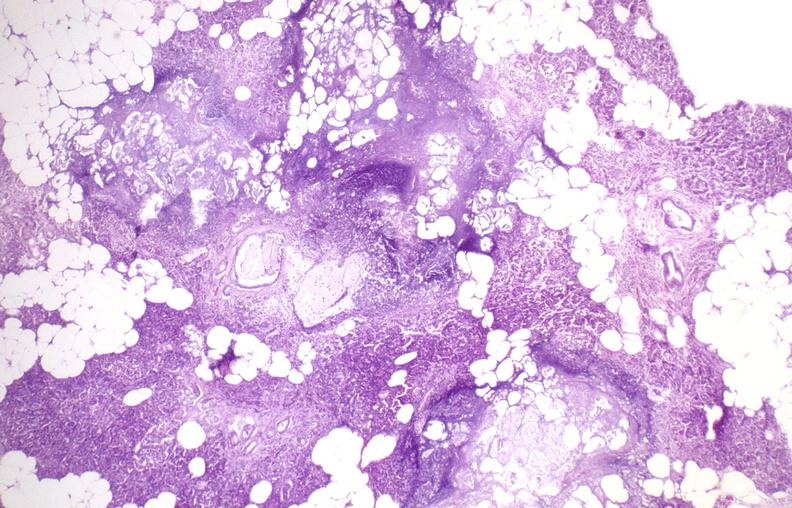does thymus show pancreatic fat necrosis?
Answer the question using a single word or phrase. No 